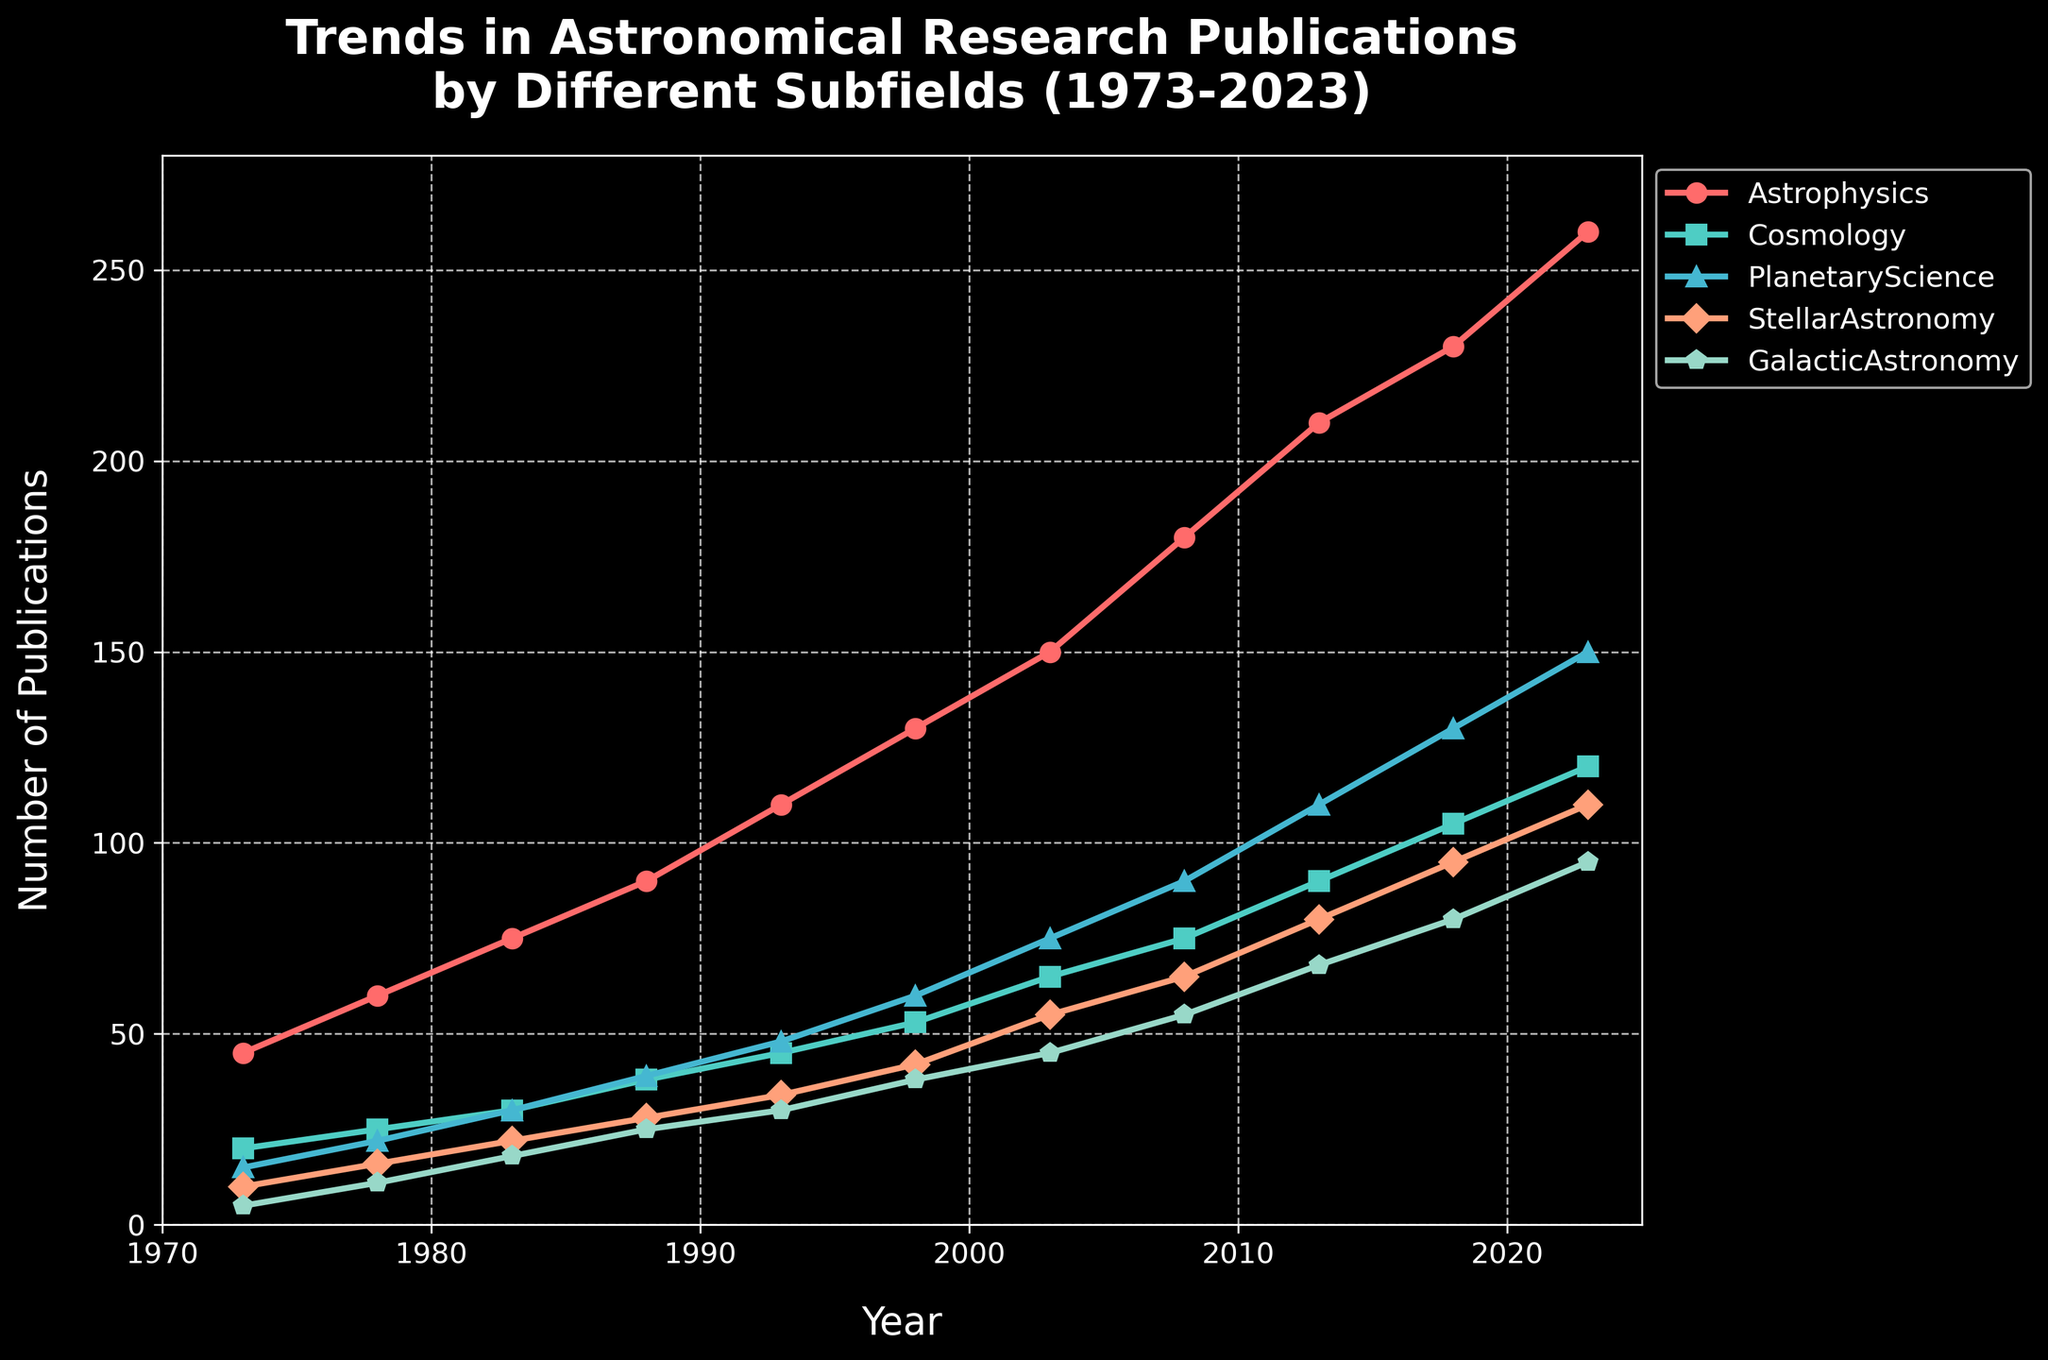What is the title of the plot? The title is usually located at the top of the plot. It provides an overview of what the plot represents. The title here is "Trends in Astronomical Research Publications by Different Subfields (1973-2023)."
Answer: Trends in Astronomical Research Publications by Different Subfields (1973-2023) What is the range of the x-axis? The x-axis represents the years in this plot. Observing the axis, the range is from 1970 to approximately 2025.
Answer: 1970 to 2025 What subfield had the highest number of publications in 1988? Look at the year 1988 on the x-axis, then check the values of each subfield at this point. The highest value among the subfields is for Astrophysics with 90 publications.
Answer: Astrophysics What is the approximate difference in the number of publications between Planetary Science and Stellar Astronomy in 2023? In 2023, find the values for both Planetary Science and Stellar Astronomy. Planetary Science has 150 publications and Stellar Astronomy has 110. The difference is 150 - 110.
Answer: 40 Which subfield showed the most significant increase in the number of publications from 1973 to 2023? Compare the starting and ending values for each subfield. Astrophysics increased from 45 to 260, which is the largest change among all subfields.
Answer: Astrophysics Which subfield had the least publications in 1973? Check the y-values for each subfield in 1973. Galactic Astronomy had the lowest value with 5 publications.
Answer: Galactic Astronomy How did the number of publications in Cosmology change from 2003 to 2018? Look at the values for Cosmology in 2003 and 2018. In 2003, there were 65 publications and in 2018, there were 105 publications. The change is 105 - 65.
Answer: Increase by 40 What is the average number of publications for the Planetary Science subfield from 1973 to 2023? Add up the publication numbers for Planetary Science in each year and divide by the number of years. (15+22+30+39+48+60+75+90+110+130+150) / 11.
Answer: 78 Which two subfields had a publication number almost equal around the year 1998? Check the values for each subfield around the year 1998. Both Stellar Astronomy (42) and Galactic Astronomy (38) had publication numbers very close to each other.
Answer: Stellar Astronomy and Galactic Astronomy What trend can be observed in the publication numbers for Astrophysics over the 50-year period? Observe the Astrophysics line over the years; it shows a steady increase from 45 in 1973 to 260 in 2023.
Answer: Steady increase 